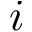Convert formula to latex. <formula><loc_0><loc_0><loc_500><loc_500>i</formula> 